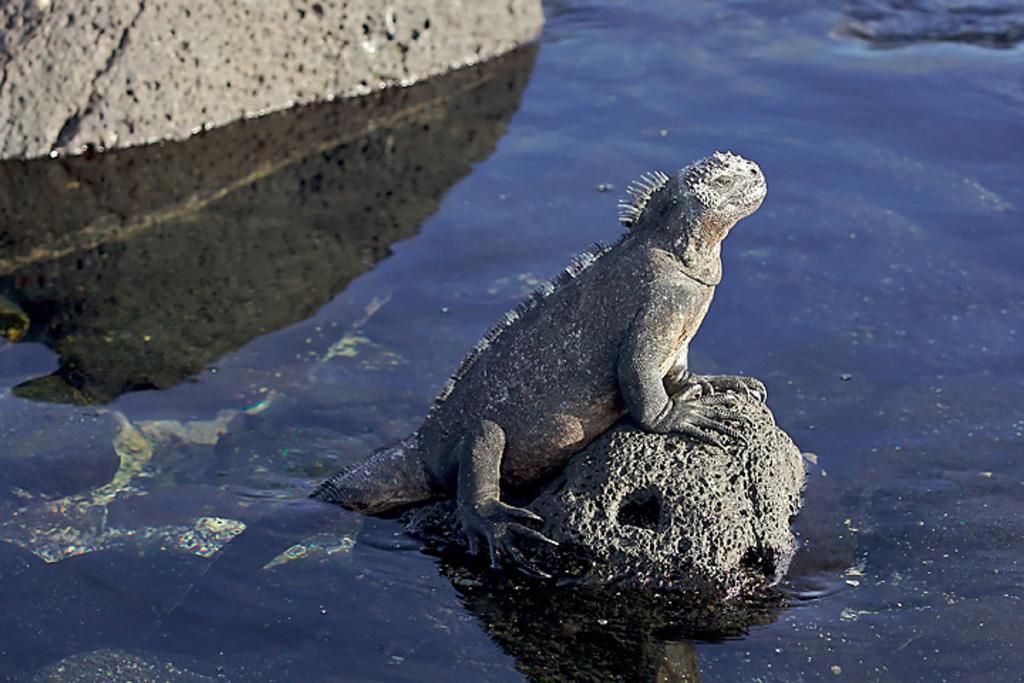Describe this image in one or two sentences. In the image there is an iguana standing on car in the middle of a lake. 